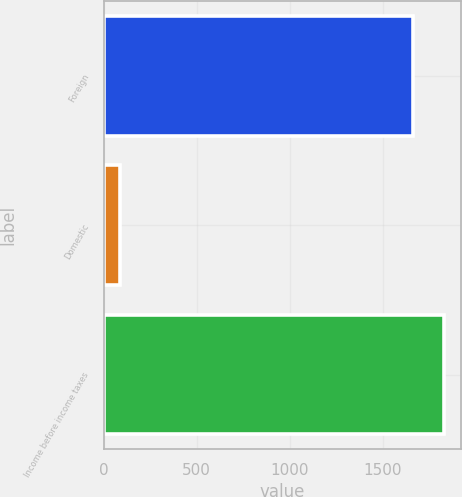Convert chart to OTSL. <chart><loc_0><loc_0><loc_500><loc_500><bar_chart><fcel>Foreign<fcel>Domestic<fcel>Income before income taxes<nl><fcel>1664<fcel>88<fcel>1830.4<nl></chart> 